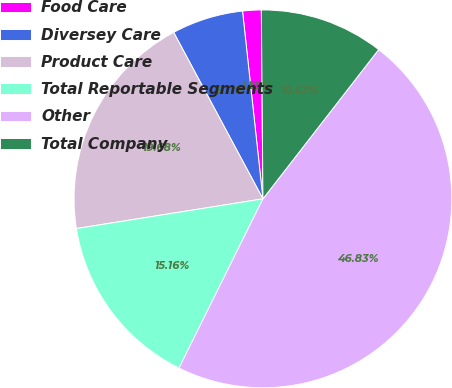Convert chart to OTSL. <chart><loc_0><loc_0><loc_500><loc_500><pie_chart><fcel>Food Care<fcel>Diversey Care<fcel>Product Care<fcel>Total Reportable Segments<fcel>Other<fcel>Total Company<nl><fcel>1.59%<fcel>6.11%<fcel>19.68%<fcel>15.16%<fcel>46.83%<fcel>10.63%<nl></chart> 